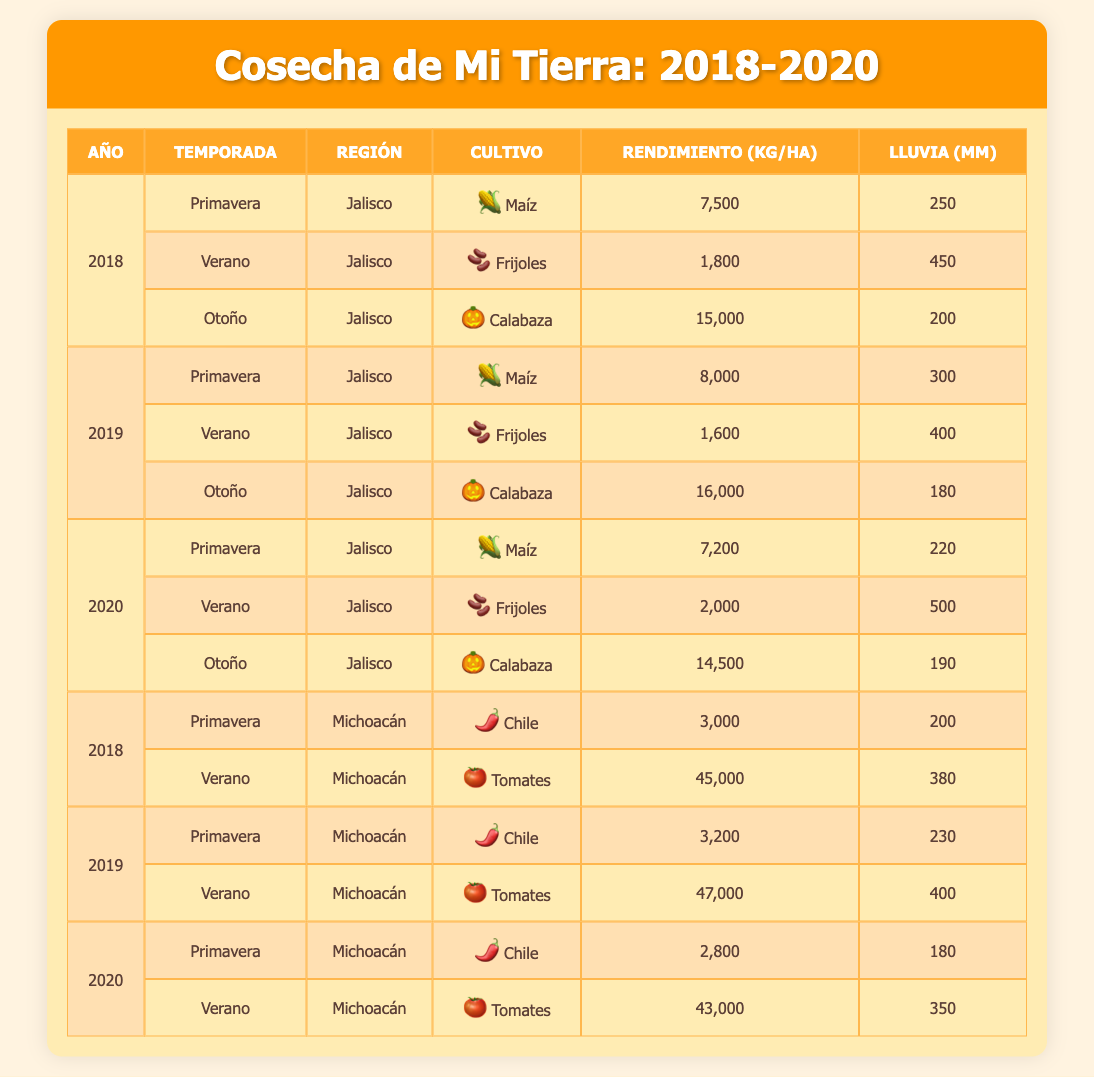What is the highest yield of squash recorded in Jalisco? The table shows yields for squash in Jalisco across three years. The yields are 15,000 kg/ha in 2018, 16,000 kg/ha in 2019, and 14,500 kg/ha in 2020. Among these, 16,000 kg/ha in 2019 is the highest.
Answer: 16,000 kg/ha Which crop had the highest yield in Michoacán in 2018? The crops in Michoacán for 2018 are chili peppers with a yield of 3,000 kg/ha and tomatoes with a yield of 45,000 kg/ha. Comparing these, tomatoes had the highest yield.
Answer: 45,000 kg/ha In which year and season did corn yield the least in Jalisco? Looking at the data for corn in Jalisco, the yields are 7,500 kg/ha in spring 2018, 8,000 kg/ha in spring 2019, and 7,200 kg/ha in spring 2020. The lowest yield is 7,200 kg/ha in spring 2020.
Answer: Spring 2020 What is the total yield of beans harvested in Jalisco from 2018 to 2020? The total yields of beans in Jalisco are 1,800 kg/ha in summer 2018, 1,600 kg/ha in summer 2019, and 2,000 kg/ha in summer 2020. Adding these, 1,800 + 1,600 + 2,000 equals 5,400 kg/ha.
Answer: 5,400 kg/ha Did the rainfall increase or decrease in Jalisco from 2018 to 2020 for the fall season? In the fall seasons for Jalisco, the rainfall was 200 mm in 2018, 180 mm in 2019, and 190 mm in 2020. From 2018 to 2019, it decreased from 200 to 180 mm, but then increased to 190 mm in 2020. Thus, there was a decrease followed by an increase.
Answer: Increased, then decreased What was the average yield of tomatoes in Michoacán over the years? The yields of tomatoes in Michoacán are 45,000 kg/ha in summer 2018, 47,000 kg/ha in summer 2019, and 43,000 kg/ha in summer 2020. To find the average, sum them up: 45,000 + 47,000 + 43,000 equals 135,000 kg/ha, then divide by 3, resulting in 45,000 kg/ha.
Answer: 45,000 kg/ha Was the rainfall higher in Jalisco in summer 2020 compared to summer 2019? The table shows summer rainfall in Jalisco was 450 mm in summer 2018, 400 mm in summer 2019, and 500 mm in summer 2020. Since 500 mm (2020) is greater than 400 mm (2019), the rainfall was indeed higher in summer 2020.
Answer: Yes What is the difference in corn yield between 2018 and 2019 in Jalisco? The corn yields in Jalisco are 7,500 kg/ha in 2018 and 8,000 kg/ha in 2019. To find the difference, subtract the 2018 yield from the 2019 yield: 8,000 - 7,500 equals 500 kg/ha.
Answer: 500 kg/ha 